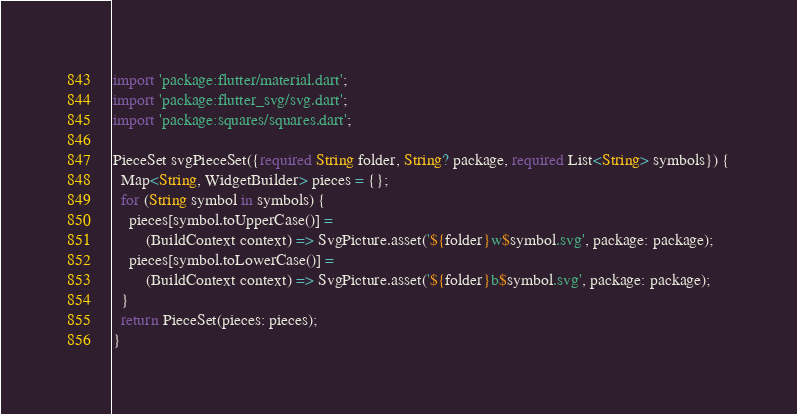Convert code to text. <code><loc_0><loc_0><loc_500><loc_500><_Dart_>import 'package:flutter/material.dart';
import 'package:flutter_svg/svg.dart';
import 'package:squares/squares.dart';

PieceSet svgPieceSet({required String folder, String? package, required List<String> symbols}) {
  Map<String, WidgetBuilder> pieces = {};
  for (String symbol in symbols) {
    pieces[symbol.toUpperCase()] =
        (BuildContext context) => SvgPicture.asset('${folder}w$symbol.svg', package: package);
    pieces[symbol.toLowerCase()] =
        (BuildContext context) => SvgPicture.asset('${folder}b$symbol.svg', package: package);
  }
  return PieceSet(pieces: pieces);
}
</code> 